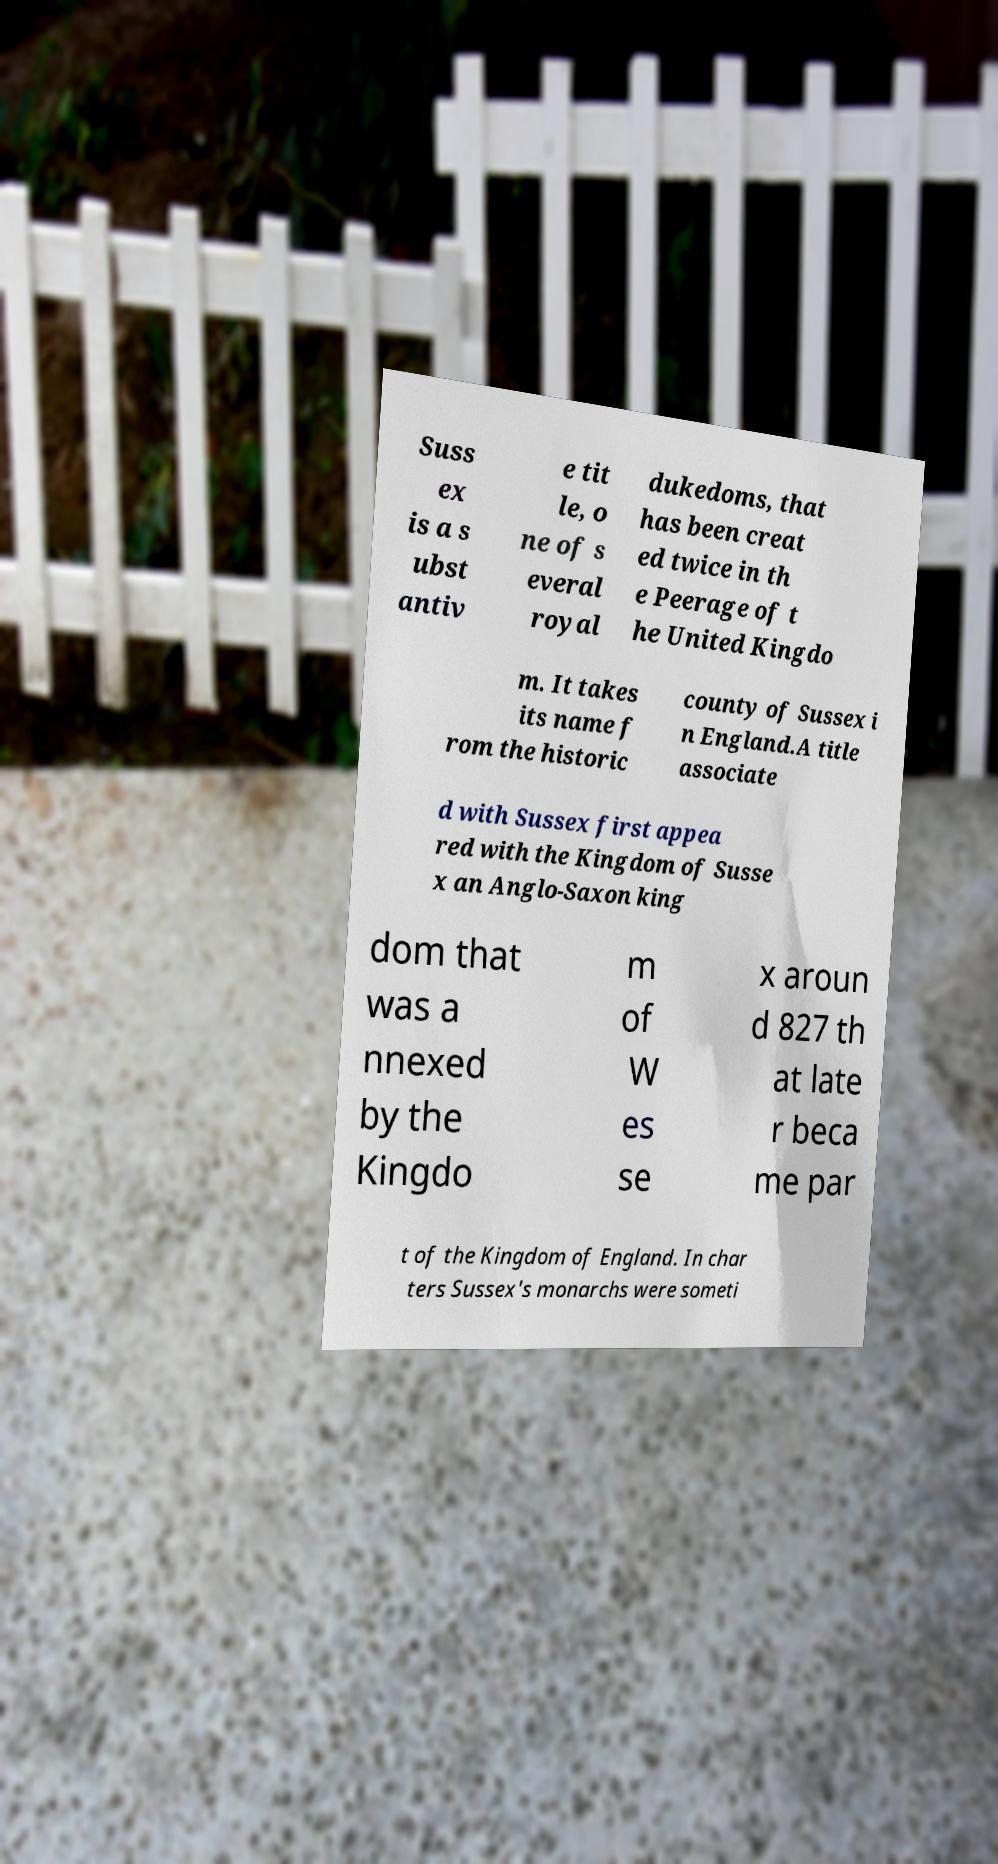Could you extract and type out the text from this image? Suss ex is a s ubst antiv e tit le, o ne of s everal royal dukedoms, that has been creat ed twice in th e Peerage of t he United Kingdo m. It takes its name f rom the historic county of Sussex i n England.A title associate d with Sussex first appea red with the Kingdom of Susse x an Anglo-Saxon king dom that was a nnexed by the Kingdo m of W es se x aroun d 827 th at late r beca me par t of the Kingdom of England. In char ters Sussex's monarchs were someti 